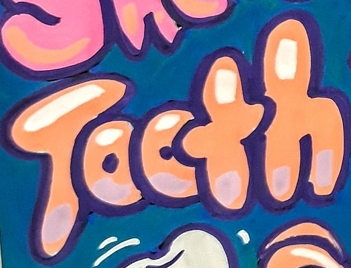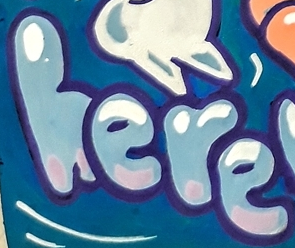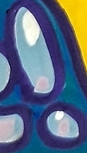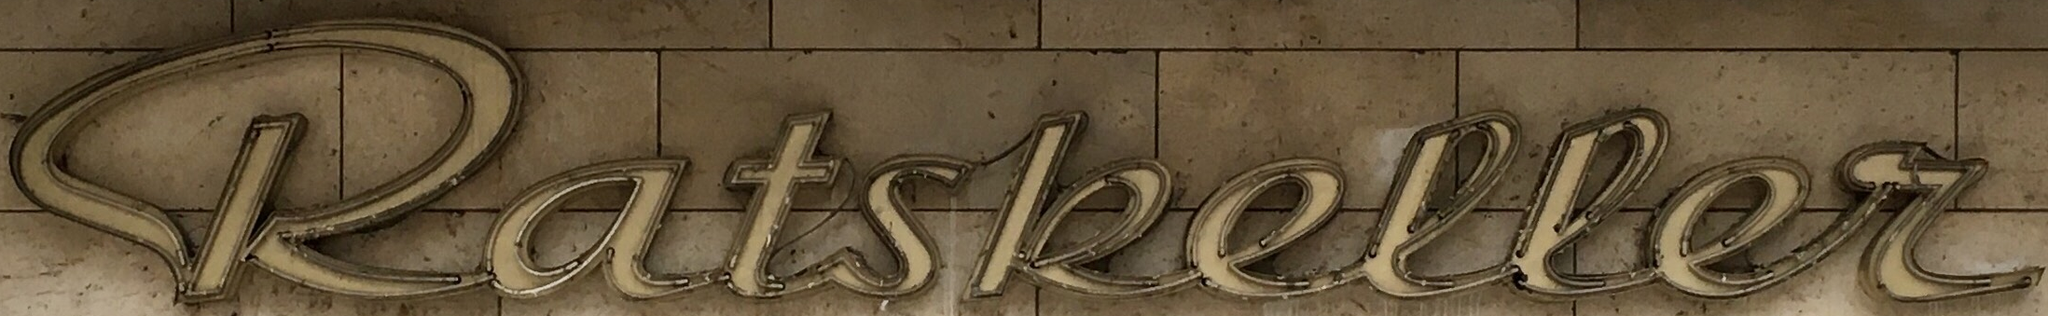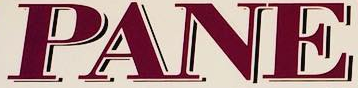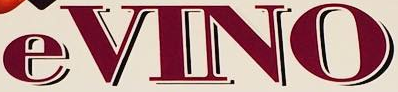Transcribe the words shown in these images in order, separated by a semicolon. Tooth; here; !; katskeller; PANE; eVINO 